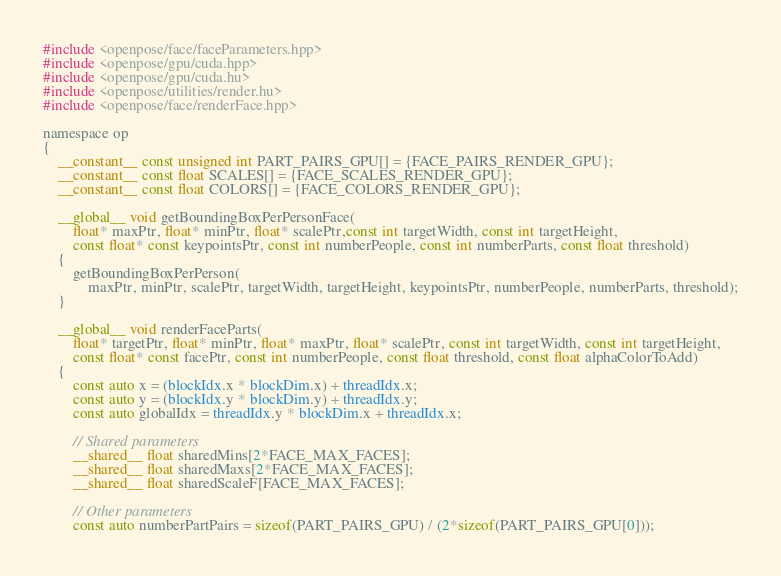<code> <loc_0><loc_0><loc_500><loc_500><_Cuda_>#include <openpose/face/faceParameters.hpp>
#include <openpose/gpu/cuda.hpp>
#include <openpose/gpu/cuda.hu>
#include <openpose/utilities/render.hu>
#include <openpose/face/renderFace.hpp>

namespace op
{
    __constant__ const unsigned int PART_PAIRS_GPU[] = {FACE_PAIRS_RENDER_GPU};
    __constant__ const float SCALES[] = {FACE_SCALES_RENDER_GPU};
    __constant__ const float COLORS[] = {FACE_COLORS_RENDER_GPU};

    __global__ void getBoundingBoxPerPersonFace(
        float* maxPtr, float* minPtr, float* scalePtr,const int targetWidth, const int targetHeight,
        const float* const keypointsPtr, const int numberPeople, const int numberParts, const float threshold)
    {
        getBoundingBoxPerPerson(
            maxPtr, minPtr, scalePtr, targetWidth, targetHeight, keypointsPtr, numberPeople, numberParts, threshold);
    }

    __global__ void renderFaceParts(
        float* targetPtr, float* minPtr, float* maxPtr, float* scalePtr, const int targetWidth, const int targetHeight,
        const float* const facePtr, const int numberPeople, const float threshold, const float alphaColorToAdd)
    {
        const auto x = (blockIdx.x * blockDim.x) + threadIdx.x;
        const auto y = (blockIdx.y * blockDim.y) + threadIdx.y;
        const auto globalIdx = threadIdx.y * blockDim.x + threadIdx.x;

        // Shared parameters
        __shared__ float sharedMins[2*FACE_MAX_FACES];
        __shared__ float sharedMaxs[2*FACE_MAX_FACES];
        __shared__ float sharedScaleF[FACE_MAX_FACES];

        // Other parameters
        const auto numberPartPairs = sizeof(PART_PAIRS_GPU) / (2*sizeof(PART_PAIRS_GPU[0]));</code> 